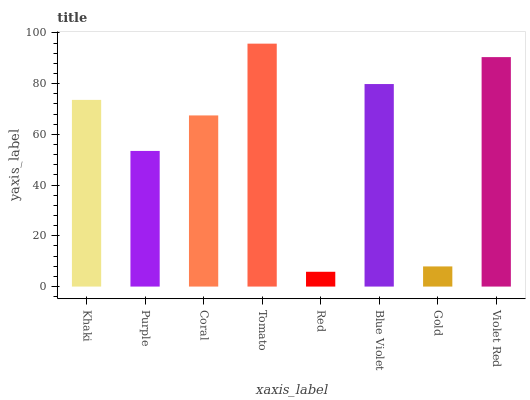Is Red the minimum?
Answer yes or no. Yes. Is Tomato the maximum?
Answer yes or no. Yes. Is Purple the minimum?
Answer yes or no. No. Is Purple the maximum?
Answer yes or no. No. Is Khaki greater than Purple?
Answer yes or no. Yes. Is Purple less than Khaki?
Answer yes or no. Yes. Is Purple greater than Khaki?
Answer yes or no. No. Is Khaki less than Purple?
Answer yes or no. No. Is Khaki the high median?
Answer yes or no. Yes. Is Coral the low median?
Answer yes or no. Yes. Is Purple the high median?
Answer yes or no. No. Is Tomato the low median?
Answer yes or no. No. 